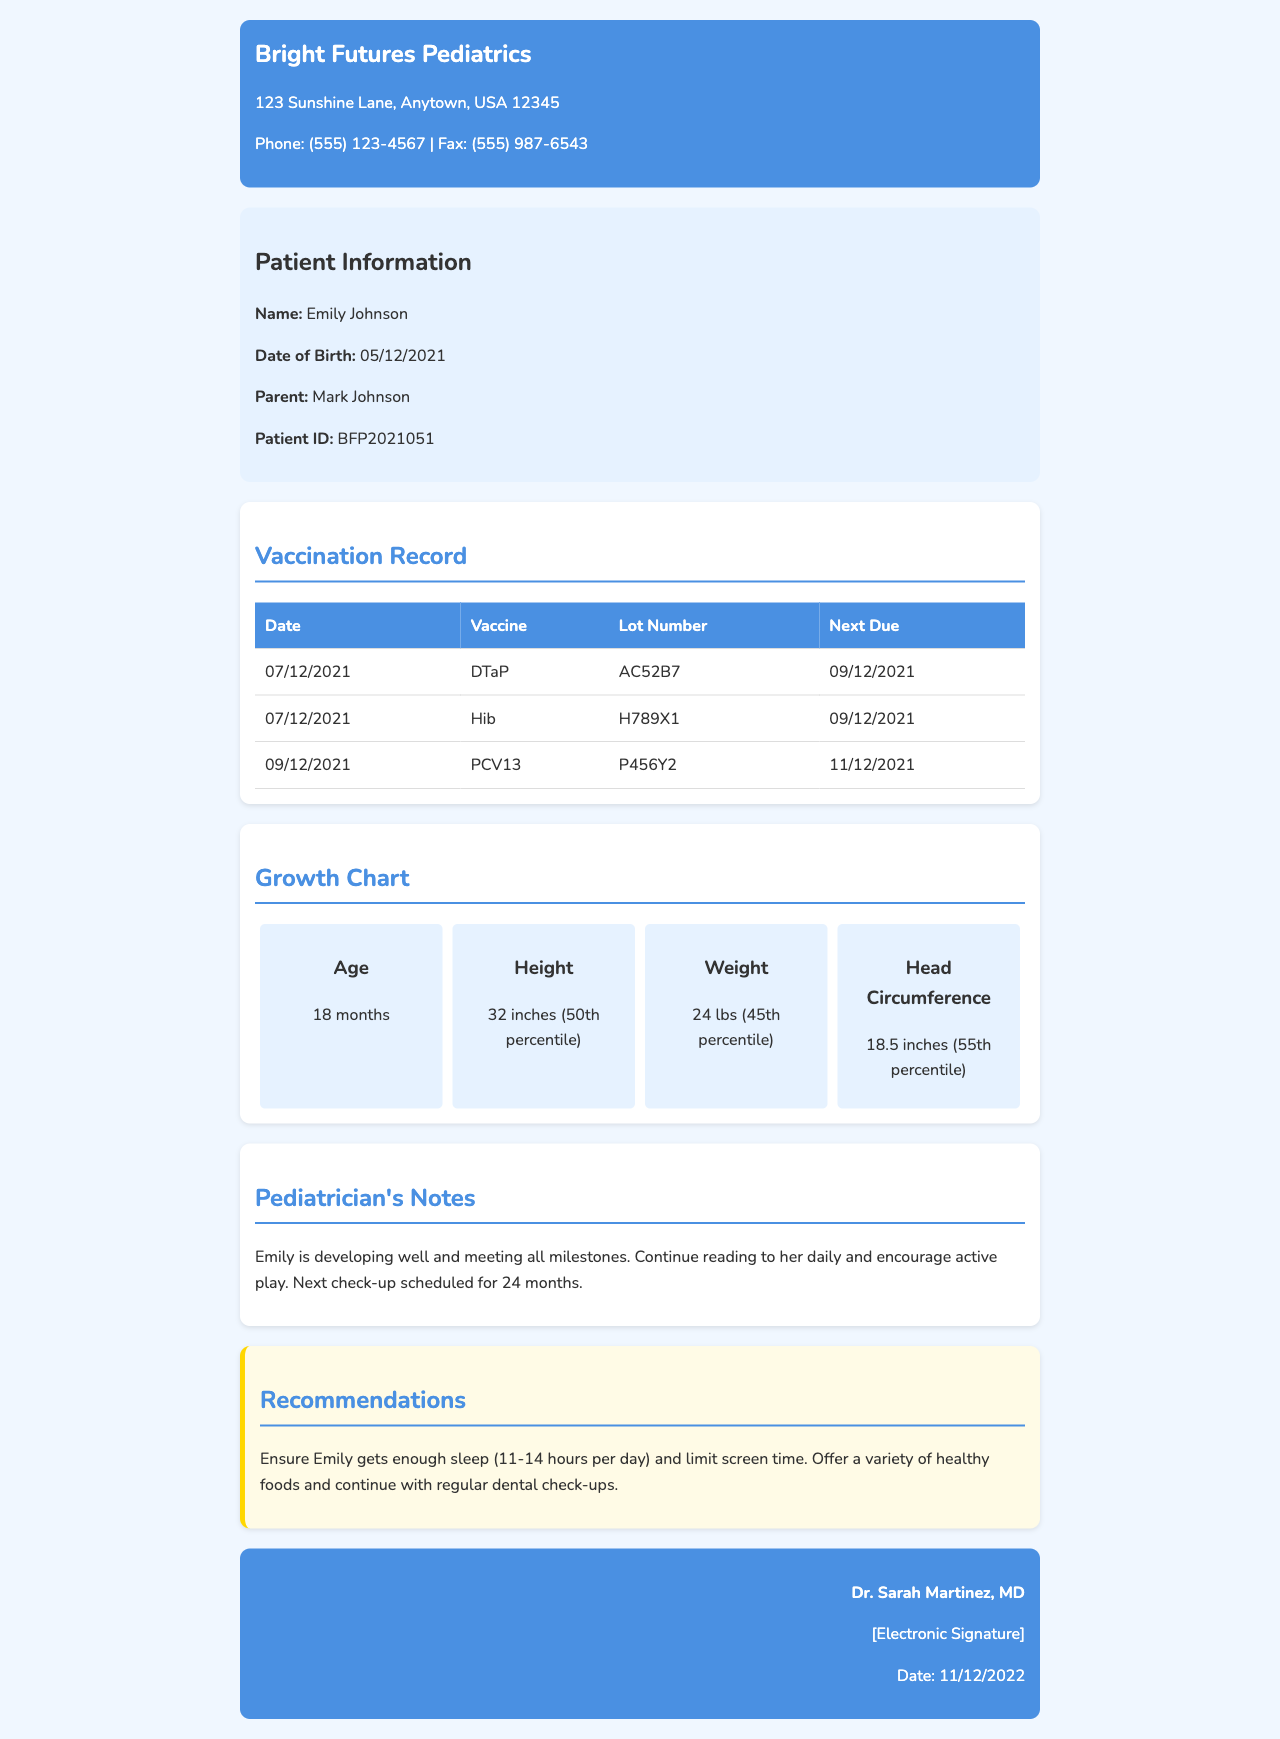What is the patient's name? The patient's name is provided in the patient information section of the document.
Answer: Emily Johnson What is the date of birth? The date of birth is mentioned in the patient information section.
Answer: 05/12/2021 What vaccine was administered on 07/12/2021? The vaccination record lists the vaccines administered on specific dates.
Answer: DTaP What is the next due date for the Hib vaccine? The next due date is specified in the vaccination record for each vaccine.
Answer: 09/12/2021 What is Emily's height at 18 months? The growth chart section details Emily's growth metrics at 18 months.
Answer: 32 inches What percentile is Emily in for her weight? The growth chart includes the percentile information for Emily's weight.
Answer: 45th percentile How often should Emily get sleep according to recommendations? The recommendations section provides advice on the amount of sleep Emily should get.
Answer: 11-14 hours per day When is Emily's next check-up scheduled? The pediatrician's notes mention the next scheduled check-up for Emily.
Answer: 24 months Who is the pediatrician listed in the report? The footer of the document contains the name of the pediatrician providing the report.
Answer: Dr. Sarah Martinez, MD 